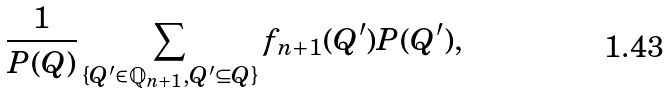<formula> <loc_0><loc_0><loc_500><loc_500>\frac { 1 } { P ( Q ) } \sum _ { \{ Q ^ { \prime } \in { \mathbb { Q } } _ { n + 1 } , Q ^ { \prime } \subseteq Q \} } f _ { n + 1 } ( Q ^ { \prime } ) P ( Q ^ { \prime } ) ,</formula> 